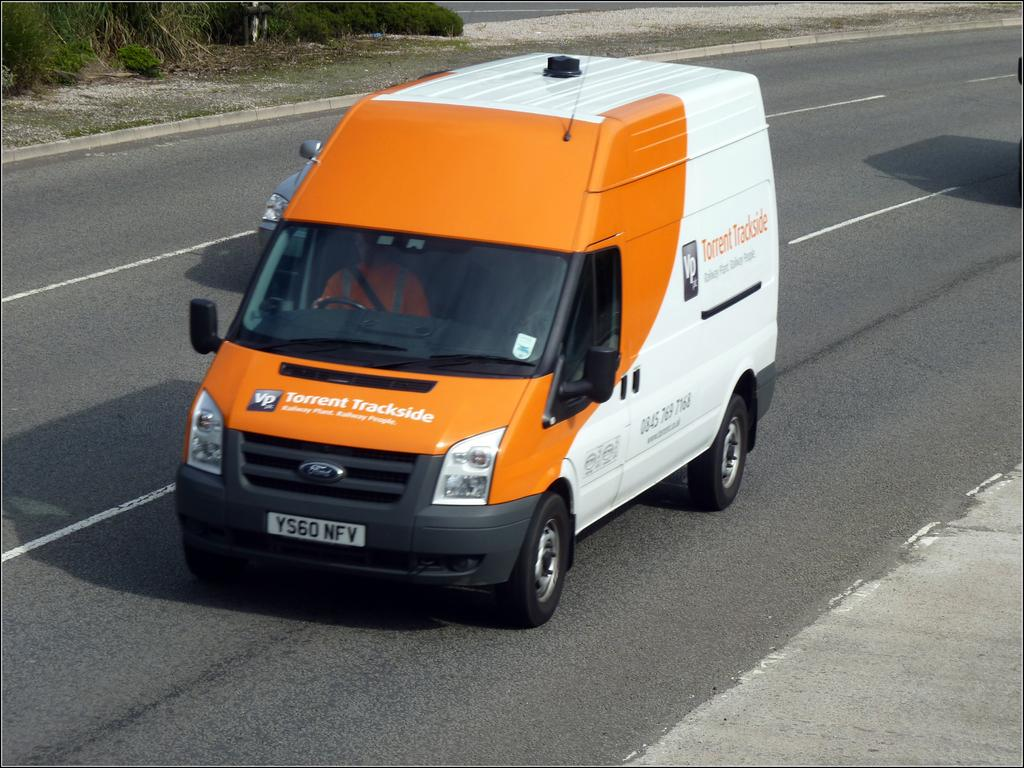<image>
Describe the image concisely. a van that has the word torrent on it 